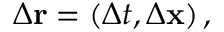<formula> <loc_0><loc_0><loc_500><loc_500>\Delta r = \left ( \Delta t , \Delta x \right ) ,</formula> 